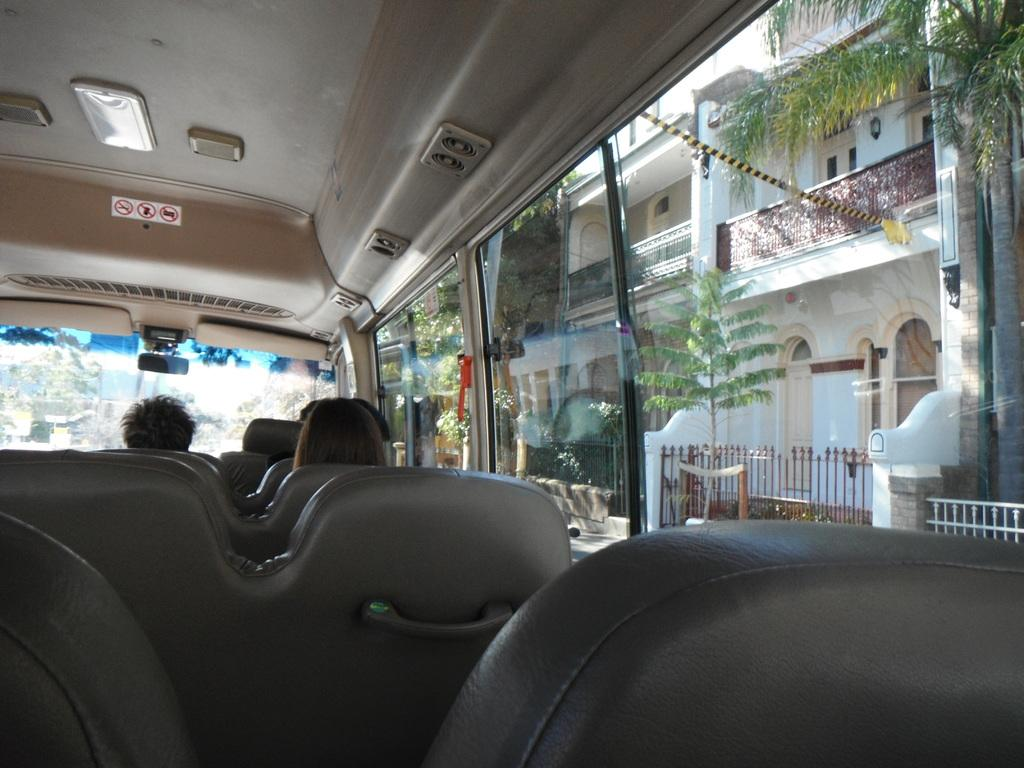What are the people in the image doing? The people in the image are sitting in a vehicle. What can be seen on the right side of the image? There are rails, trees, and a building on the right side of the image. What type of farm animals can be seen grazing in the image? There are no farm animals present in the image. What is the people's lunch preference in the image? There is no information about the people's lunch preferences in the image. 